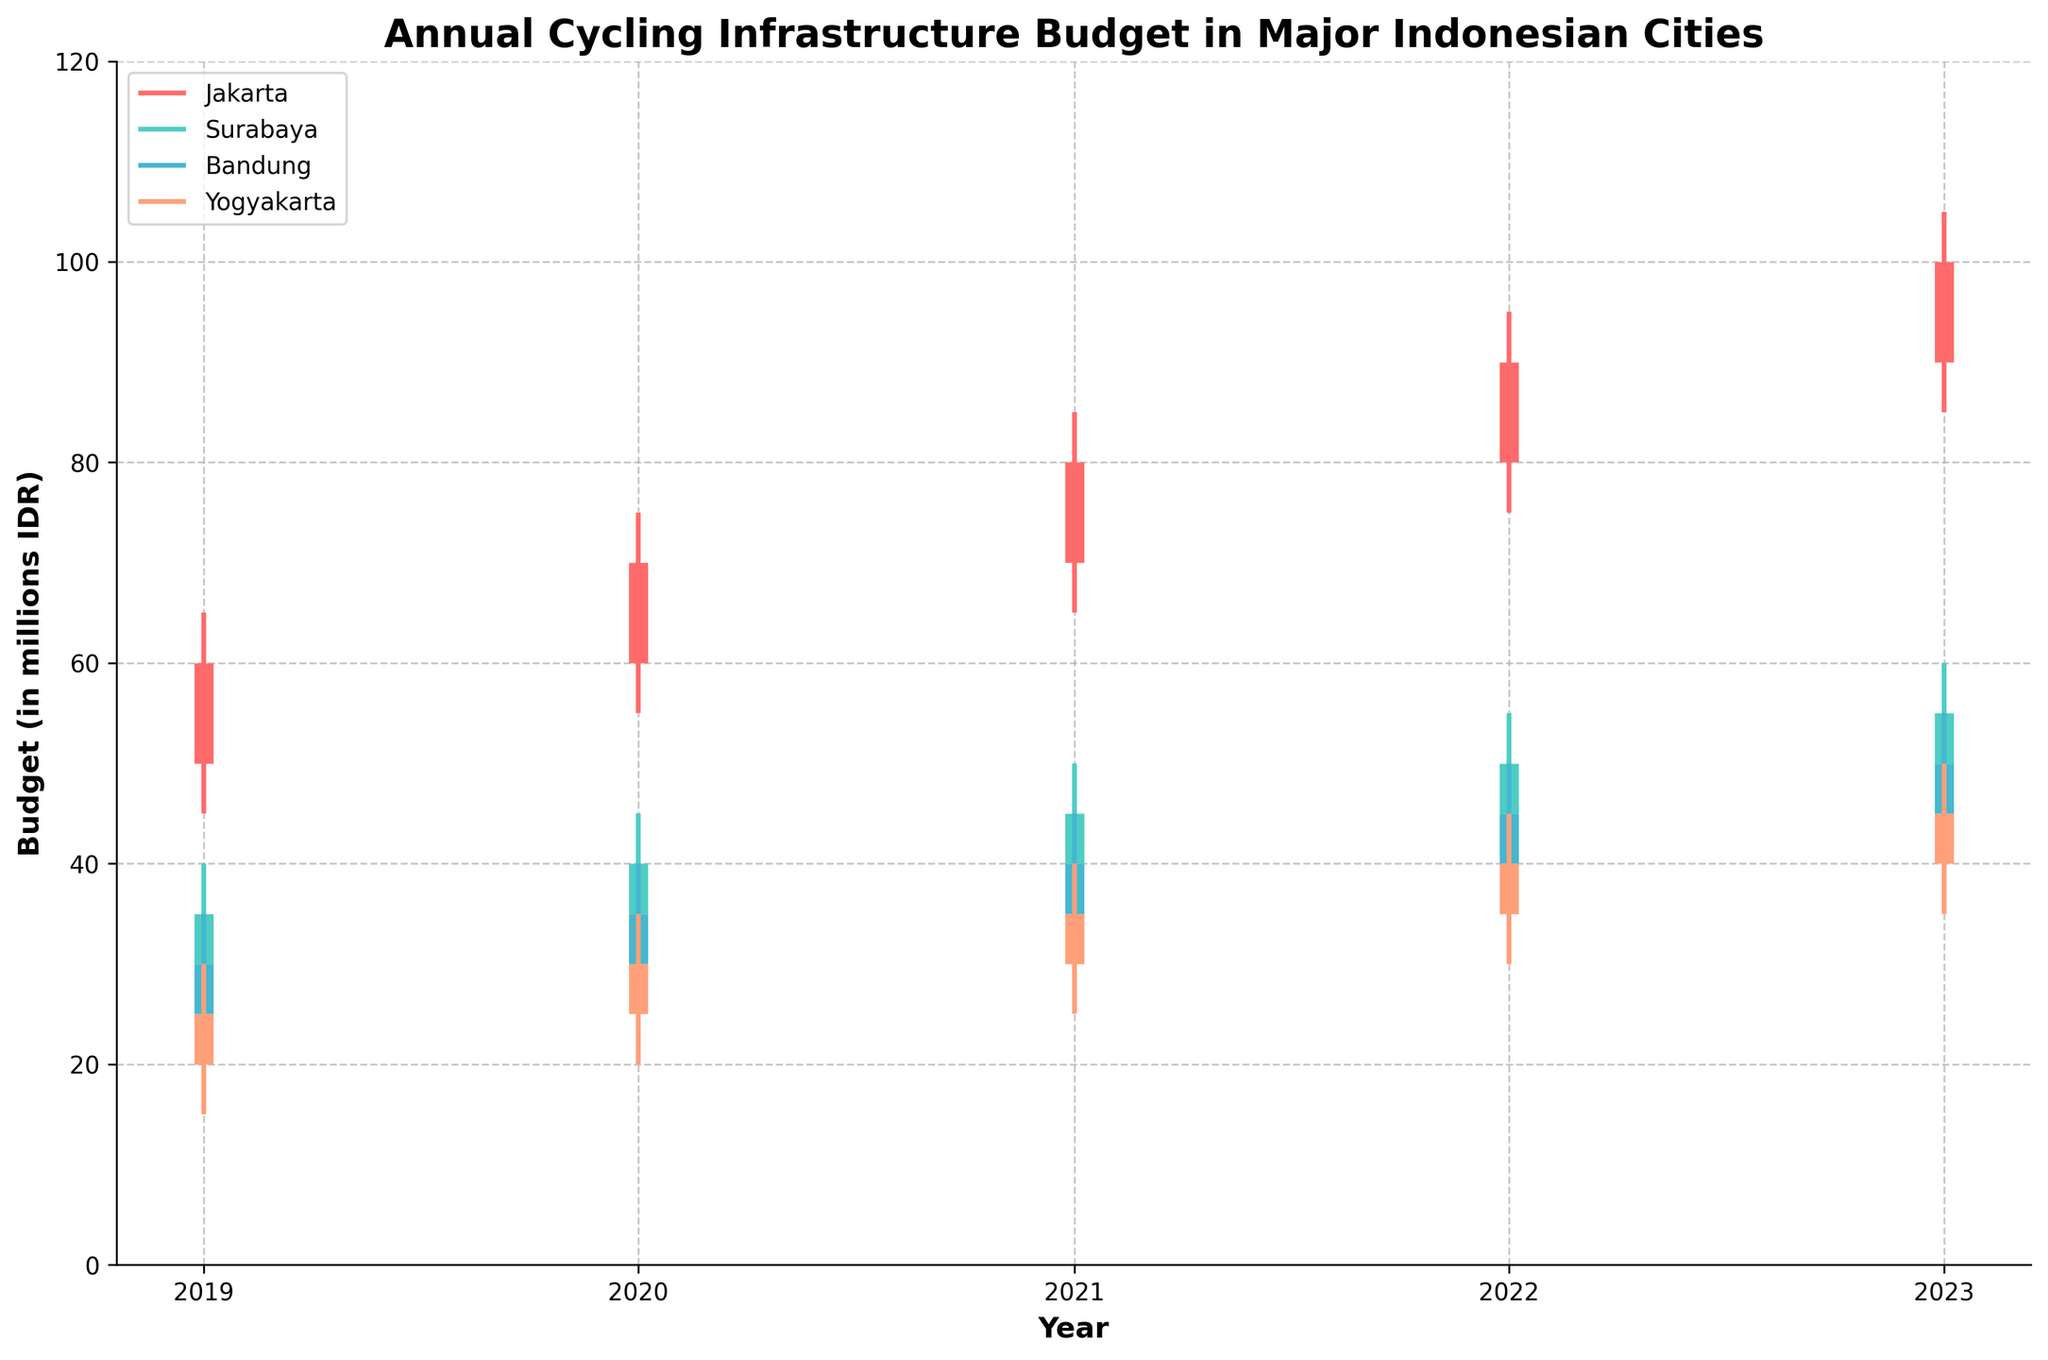What is the title of the figure? The title is clearly written at the top of the figure. It is "Annual Cycling Infrastructure Budget in Major Indonesian Cities."
Answer: Annual Cycling Infrastructure Budget in Major Indonesian Cities Which city had the highest budget allocation in 2023? By looking at the high values for each city in 2023, Jakarta has the highest high value of 105 million IDR.
Answer: Jakarta How many cities are included in the figure? The figure shows data for four unique colors, each representing a different city.
Answer: Four What years are covered in the figure? The x-axis spans a range from 2019 to 2023, indicating the covered years.
Answer: 2019 to 2023 What is the average closing budget for Bandung over the years displayed? Sum the closing budgets for Bandung from 2019 to 2023 (30+35+40+45+50) and divide by the number of years, which is 5. (30+35+40+45+50)/5 = 40
Answer: 40 What is the total high budget for Yogyakarta from 2019 to 2023? Add the high values for Yogyakarta from each year: 30, 35, 40, 45, and 50. 30 + 35 + 40 + 45 + 50 = 200
Answer: 200 Which city experienced the greatest increase in closing budget from 2019 to 2023? Compare the increase in closing budgets for all cities between 2019 and 2023. Jakarta increased from 60 to 100, Surabaya from 35 to 55, Bandung from 30 to 50, and Yogyakarta from 25 to 45. The increase for Jakarta is the greatest at 40.
Answer: Jakarta Did any city have a decreasing budget in any year? Look at the open and close values for each city in each year to see if the close value is lower than the open value. None of the cities have a decreasing budget in any year.
Answer: No Which city had the smallest range in its budget allocation in 2021? Determine the range (High - Low) for each city in 2021: Jakarta (85-65), Surabaya (50-35), Bandung (45-30), Yogyakarta (40-25). Bandung and Yogyakarta both have the smallest range of 15.
Answer: Bandung and Yogyakarta What is the budget trend for Surabaya from 2019 to 2023? Observe the OHLC bars for Surabaya and note that the close budget increases gradually each year from 35 in 2019 to 55 in 2023, indicating an upward trend.
Answer: Upward trend Which city's budget had the highest volatility in 2020? Volatility can be observed by the range between the high and low values. In 2020, Jakarta has the highest range (20) compared to Surabaya (15), Bandung (15), and Yogyakarta (15).
Answer: Jakarta 